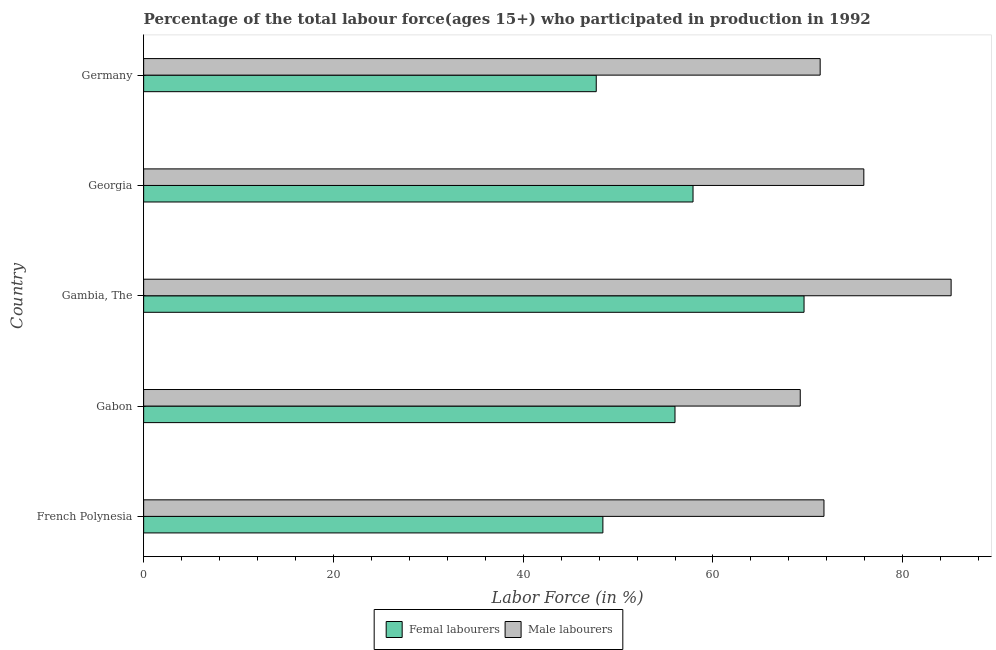How many different coloured bars are there?
Offer a very short reply. 2. How many groups of bars are there?
Give a very brief answer. 5. Are the number of bars per tick equal to the number of legend labels?
Ensure brevity in your answer.  Yes. How many bars are there on the 4th tick from the top?
Offer a very short reply. 2. What is the label of the 3rd group of bars from the top?
Your answer should be very brief. Gambia, The. What is the percentage of female labor force in Georgia?
Offer a very short reply. 57.9. Across all countries, what is the maximum percentage of male labour force?
Ensure brevity in your answer.  85.1. Across all countries, what is the minimum percentage of female labor force?
Ensure brevity in your answer.  47.7. In which country was the percentage of male labour force maximum?
Offer a terse response. Gambia, The. In which country was the percentage of male labour force minimum?
Give a very brief answer. Gabon. What is the total percentage of male labour force in the graph?
Your answer should be very brief. 373.2. What is the difference between the percentage of male labour force in Gabon and that in Germany?
Provide a short and direct response. -2.1. What is the difference between the percentage of female labor force in Gambia, The and the percentage of male labour force in Georgia?
Make the answer very short. -6.3. What is the average percentage of male labour force per country?
Offer a terse response. 74.64. What is the difference between the percentage of female labor force and percentage of male labour force in Gabon?
Ensure brevity in your answer.  -13.2. In how many countries, is the percentage of female labor force greater than 72 %?
Your answer should be very brief. 0. What is the ratio of the percentage of male labour force in French Polynesia to that in Georgia?
Give a very brief answer. 0.94. Is the percentage of female labor force in French Polynesia less than that in Georgia?
Offer a terse response. Yes. What is the difference between the highest and the second highest percentage of female labor force?
Provide a succinct answer. 11.7. In how many countries, is the percentage of male labour force greater than the average percentage of male labour force taken over all countries?
Give a very brief answer. 2. Is the sum of the percentage of female labor force in Georgia and Germany greater than the maximum percentage of male labour force across all countries?
Your answer should be compact. Yes. What does the 2nd bar from the top in French Polynesia represents?
Provide a short and direct response. Femal labourers. What does the 2nd bar from the bottom in Gabon represents?
Your answer should be very brief. Male labourers. How many bars are there?
Provide a succinct answer. 10. How many countries are there in the graph?
Make the answer very short. 5. What is the difference between two consecutive major ticks on the X-axis?
Keep it short and to the point. 20. Are the values on the major ticks of X-axis written in scientific E-notation?
Offer a terse response. No. Does the graph contain any zero values?
Ensure brevity in your answer.  No. Does the graph contain grids?
Your answer should be compact. No. Where does the legend appear in the graph?
Your answer should be compact. Bottom center. How many legend labels are there?
Offer a terse response. 2. What is the title of the graph?
Give a very brief answer. Percentage of the total labour force(ages 15+) who participated in production in 1992. What is the Labor Force (in %) of Femal labourers in French Polynesia?
Provide a succinct answer. 48.4. What is the Labor Force (in %) in Male labourers in French Polynesia?
Your response must be concise. 71.7. What is the Labor Force (in %) in Male labourers in Gabon?
Give a very brief answer. 69.2. What is the Labor Force (in %) in Femal labourers in Gambia, The?
Offer a very short reply. 69.6. What is the Labor Force (in %) in Male labourers in Gambia, The?
Your answer should be compact. 85.1. What is the Labor Force (in %) of Femal labourers in Georgia?
Keep it short and to the point. 57.9. What is the Labor Force (in %) of Male labourers in Georgia?
Ensure brevity in your answer.  75.9. What is the Labor Force (in %) in Femal labourers in Germany?
Keep it short and to the point. 47.7. What is the Labor Force (in %) in Male labourers in Germany?
Provide a short and direct response. 71.3. Across all countries, what is the maximum Labor Force (in %) of Femal labourers?
Offer a terse response. 69.6. Across all countries, what is the maximum Labor Force (in %) in Male labourers?
Give a very brief answer. 85.1. Across all countries, what is the minimum Labor Force (in %) of Femal labourers?
Your answer should be compact. 47.7. Across all countries, what is the minimum Labor Force (in %) in Male labourers?
Offer a terse response. 69.2. What is the total Labor Force (in %) in Femal labourers in the graph?
Make the answer very short. 279.6. What is the total Labor Force (in %) in Male labourers in the graph?
Offer a very short reply. 373.2. What is the difference between the Labor Force (in %) in Femal labourers in French Polynesia and that in Gabon?
Offer a terse response. -7.6. What is the difference between the Labor Force (in %) in Male labourers in French Polynesia and that in Gabon?
Offer a terse response. 2.5. What is the difference between the Labor Force (in %) in Femal labourers in French Polynesia and that in Gambia, The?
Offer a very short reply. -21.2. What is the difference between the Labor Force (in %) in Femal labourers in French Polynesia and that in Georgia?
Your answer should be compact. -9.5. What is the difference between the Labor Force (in %) of Male labourers in French Polynesia and that in Georgia?
Keep it short and to the point. -4.2. What is the difference between the Labor Force (in %) in Male labourers in Gabon and that in Gambia, The?
Your answer should be compact. -15.9. What is the difference between the Labor Force (in %) of Femal labourers in Gabon and that in Georgia?
Offer a very short reply. -1.9. What is the difference between the Labor Force (in %) in Femal labourers in Gabon and that in Germany?
Your answer should be very brief. 8.3. What is the difference between the Labor Force (in %) in Femal labourers in Gambia, The and that in Germany?
Offer a terse response. 21.9. What is the difference between the Labor Force (in %) of Femal labourers in Georgia and that in Germany?
Ensure brevity in your answer.  10.2. What is the difference between the Labor Force (in %) of Femal labourers in French Polynesia and the Labor Force (in %) of Male labourers in Gabon?
Keep it short and to the point. -20.8. What is the difference between the Labor Force (in %) in Femal labourers in French Polynesia and the Labor Force (in %) in Male labourers in Gambia, The?
Keep it short and to the point. -36.7. What is the difference between the Labor Force (in %) in Femal labourers in French Polynesia and the Labor Force (in %) in Male labourers in Georgia?
Your answer should be very brief. -27.5. What is the difference between the Labor Force (in %) in Femal labourers in French Polynesia and the Labor Force (in %) in Male labourers in Germany?
Provide a succinct answer. -22.9. What is the difference between the Labor Force (in %) in Femal labourers in Gabon and the Labor Force (in %) in Male labourers in Gambia, The?
Offer a very short reply. -29.1. What is the difference between the Labor Force (in %) in Femal labourers in Gabon and the Labor Force (in %) in Male labourers in Georgia?
Keep it short and to the point. -19.9. What is the difference between the Labor Force (in %) of Femal labourers in Gabon and the Labor Force (in %) of Male labourers in Germany?
Give a very brief answer. -15.3. What is the average Labor Force (in %) in Femal labourers per country?
Give a very brief answer. 55.92. What is the average Labor Force (in %) in Male labourers per country?
Your answer should be very brief. 74.64. What is the difference between the Labor Force (in %) of Femal labourers and Labor Force (in %) of Male labourers in French Polynesia?
Your answer should be very brief. -23.3. What is the difference between the Labor Force (in %) of Femal labourers and Labor Force (in %) of Male labourers in Gabon?
Your answer should be very brief. -13.2. What is the difference between the Labor Force (in %) of Femal labourers and Labor Force (in %) of Male labourers in Gambia, The?
Your response must be concise. -15.5. What is the difference between the Labor Force (in %) in Femal labourers and Labor Force (in %) in Male labourers in Georgia?
Your response must be concise. -18. What is the difference between the Labor Force (in %) in Femal labourers and Labor Force (in %) in Male labourers in Germany?
Offer a terse response. -23.6. What is the ratio of the Labor Force (in %) in Femal labourers in French Polynesia to that in Gabon?
Provide a succinct answer. 0.86. What is the ratio of the Labor Force (in %) in Male labourers in French Polynesia to that in Gabon?
Offer a terse response. 1.04. What is the ratio of the Labor Force (in %) of Femal labourers in French Polynesia to that in Gambia, The?
Offer a terse response. 0.7. What is the ratio of the Labor Force (in %) in Male labourers in French Polynesia to that in Gambia, The?
Make the answer very short. 0.84. What is the ratio of the Labor Force (in %) in Femal labourers in French Polynesia to that in Georgia?
Your answer should be very brief. 0.84. What is the ratio of the Labor Force (in %) of Male labourers in French Polynesia to that in Georgia?
Make the answer very short. 0.94. What is the ratio of the Labor Force (in %) in Femal labourers in French Polynesia to that in Germany?
Your answer should be very brief. 1.01. What is the ratio of the Labor Force (in %) in Male labourers in French Polynesia to that in Germany?
Provide a succinct answer. 1.01. What is the ratio of the Labor Force (in %) of Femal labourers in Gabon to that in Gambia, The?
Your response must be concise. 0.8. What is the ratio of the Labor Force (in %) of Male labourers in Gabon to that in Gambia, The?
Your response must be concise. 0.81. What is the ratio of the Labor Force (in %) of Femal labourers in Gabon to that in Georgia?
Keep it short and to the point. 0.97. What is the ratio of the Labor Force (in %) of Male labourers in Gabon to that in Georgia?
Ensure brevity in your answer.  0.91. What is the ratio of the Labor Force (in %) of Femal labourers in Gabon to that in Germany?
Offer a terse response. 1.17. What is the ratio of the Labor Force (in %) of Male labourers in Gabon to that in Germany?
Make the answer very short. 0.97. What is the ratio of the Labor Force (in %) in Femal labourers in Gambia, The to that in Georgia?
Provide a succinct answer. 1.2. What is the ratio of the Labor Force (in %) of Male labourers in Gambia, The to that in Georgia?
Your answer should be very brief. 1.12. What is the ratio of the Labor Force (in %) in Femal labourers in Gambia, The to that in Germany?
Make the answer very short. 1.46. What is the ratio of the Labor Force (in %) of Male labourers in Gambia, The to that in Germany?
Keep it short and to the point. 1.19. What is the ratio of the Labor Force (in %) of Femal labourers in Georgia to that in Germany?
Make the answer very short. 1.21. What is the ratio of the Labor Force (in %) in Male labourers in Georgia to that in Germany?
Offer a terse response. 1.06. What is the difference between the highest and the lowest Labor Force (in %) of Femal labourers?
Provide a short and direct response. 21.9. 